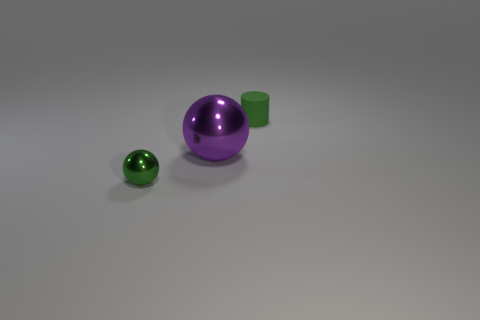Considering their colors and shapes, what uses could these objects have? The objects could serve a variety of purposes. The small green sphere could be a decorative marble or part of a game set. The green cylinder might function as a container or a stand for the larger sphere. The purple sphere could be a decorative piece, or in a practical sense, it could be part of a larger assembly, acting as a knob or a roller. 